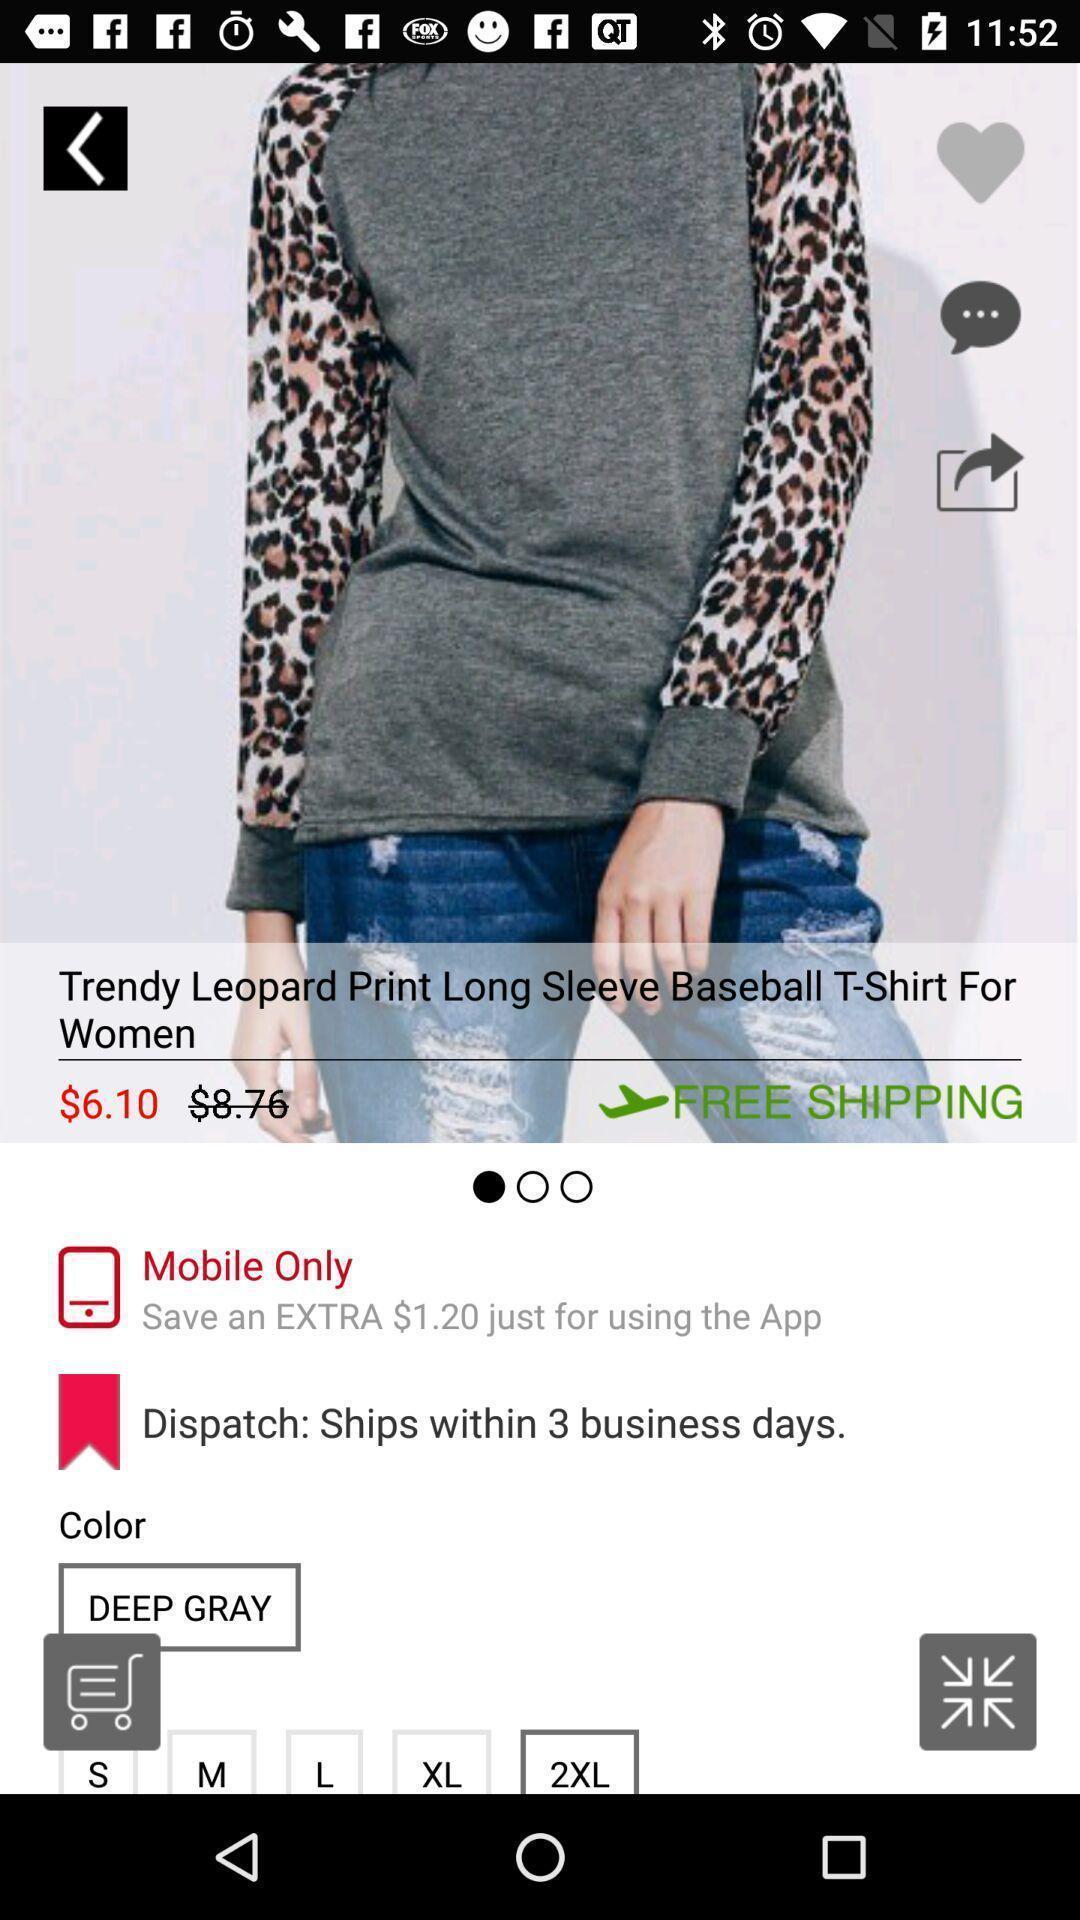Please provide a description for this image. Screen displaying t-shirt in a shopping app. 